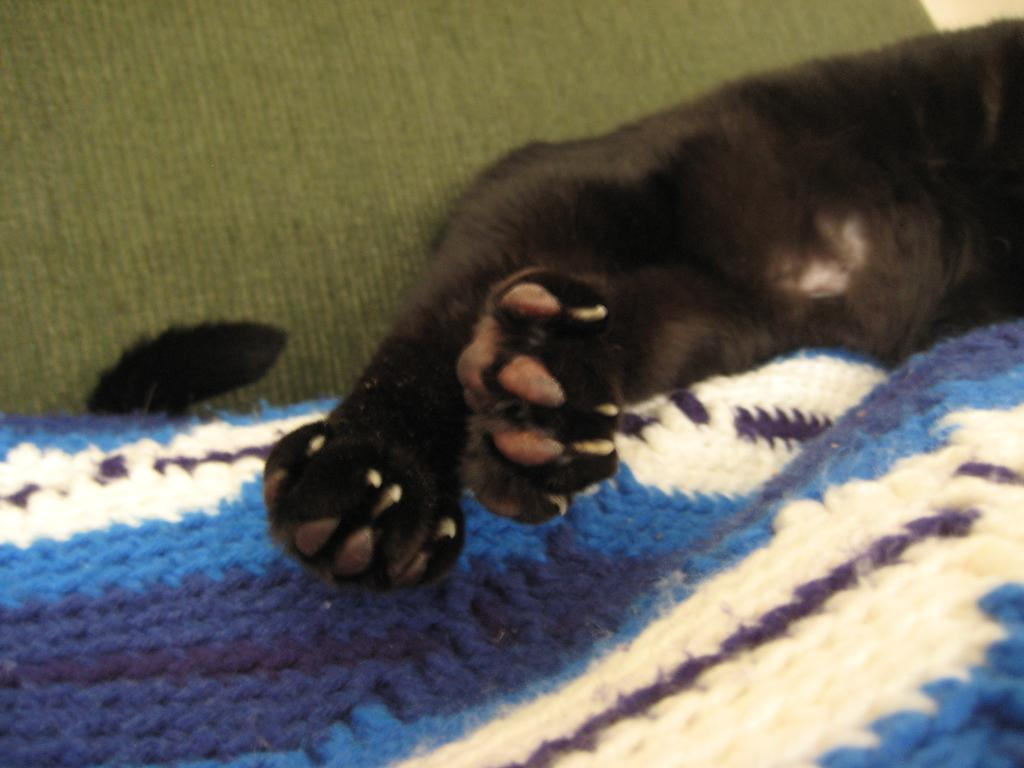What type of animal can be inferred from the legs and tail visible in the image? It is difficult to determine the exact type of animal from the legs and tail alone, but it is likely a four-legged animal with a tail. What material is the cloth in the image made of? The cloth in the image is made of wool. How does the animal use the brake in the image? There is no brake present in the image; it is a wool cloth and animal legs and tail. What sense does the animal use to detect the wool cloth in the image? The image does not provide information about the animal's senses or how it might detect the wool cloth. 